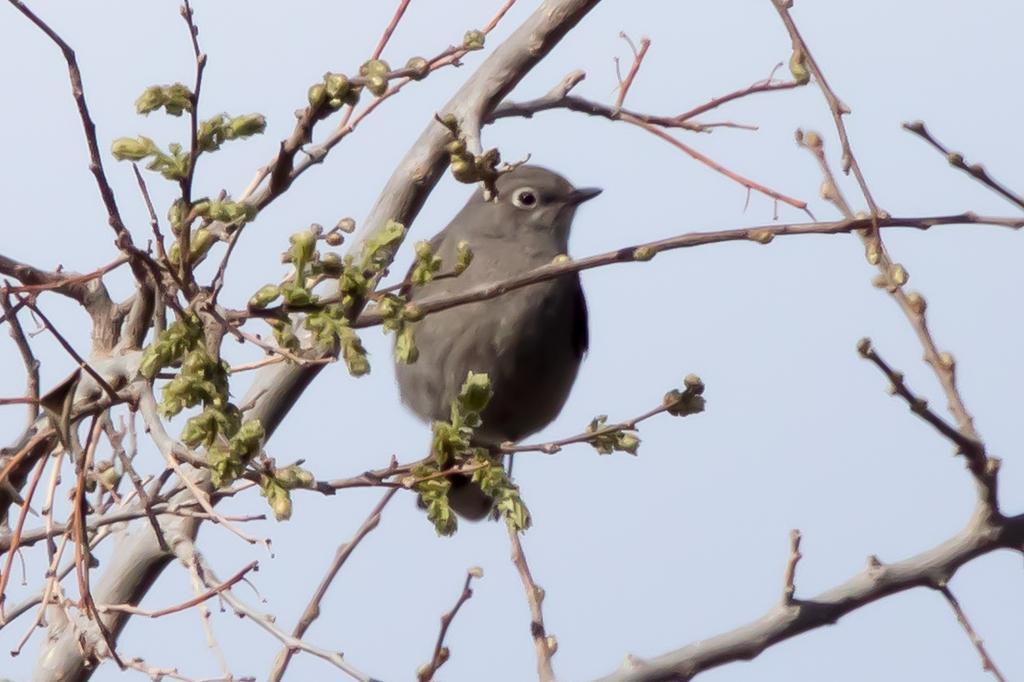In one or two sentences, can you explain what this image depicts? In the image in the center we can see one tree. And we can see one bird sitting on the branch,which is in ash color. In the background we can see the sky. 